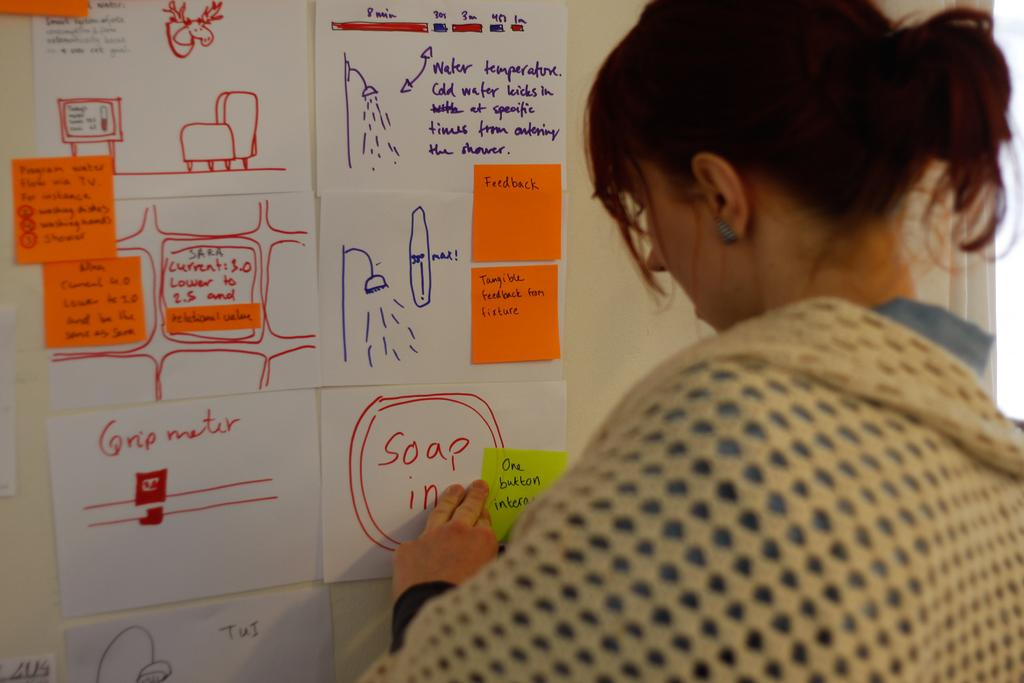What is happening in the image? There is a person in the image who is sticking a paper on a wall. Can you describe the person's action in more detail? The person is using their hand to attach the paper to the wall. What type of wind can be seen blowing the paper in the image? There is no wind present in the image; the person is sticking the paper on the wall. What is the person using to tighten the ground in the image? There is no ground or wrench present in the image; the person is only sticking a paper on a wall. 